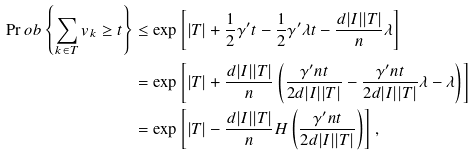<formula> <loc_0><loc_0><loc_500><loc_500>\Pr o b \left \{ \sum _ { k \in T } v _ { k } \geq t \right \} & \leq \exp \left [ | T | + \frac { 1 } { 2 } \gamma ^ { \prime } t - \frac { 1 } { 2 } \gamma ^ { \prime } \lambda t - \frac { d | I | | T | } { n } \lambda \right ] \\ & = \exp \left [ | T | + \frac { d | I | | T | } { n } \left ( \frac { \gamma ^ { \prime } n t } { 2 d | I | | T | } - \frac { \gamma ^ { \prime } n t } { 2 d | I | | T | } \lambda - \lambda \right ) \right ] \\ & = \exp \left [ | T | - \frac { d | I | | T | } { n } H \left ( \frac { \gamma ^ { \prime } n t } { 2 d | I | | T | } \right ) \right ] ,</formula> 